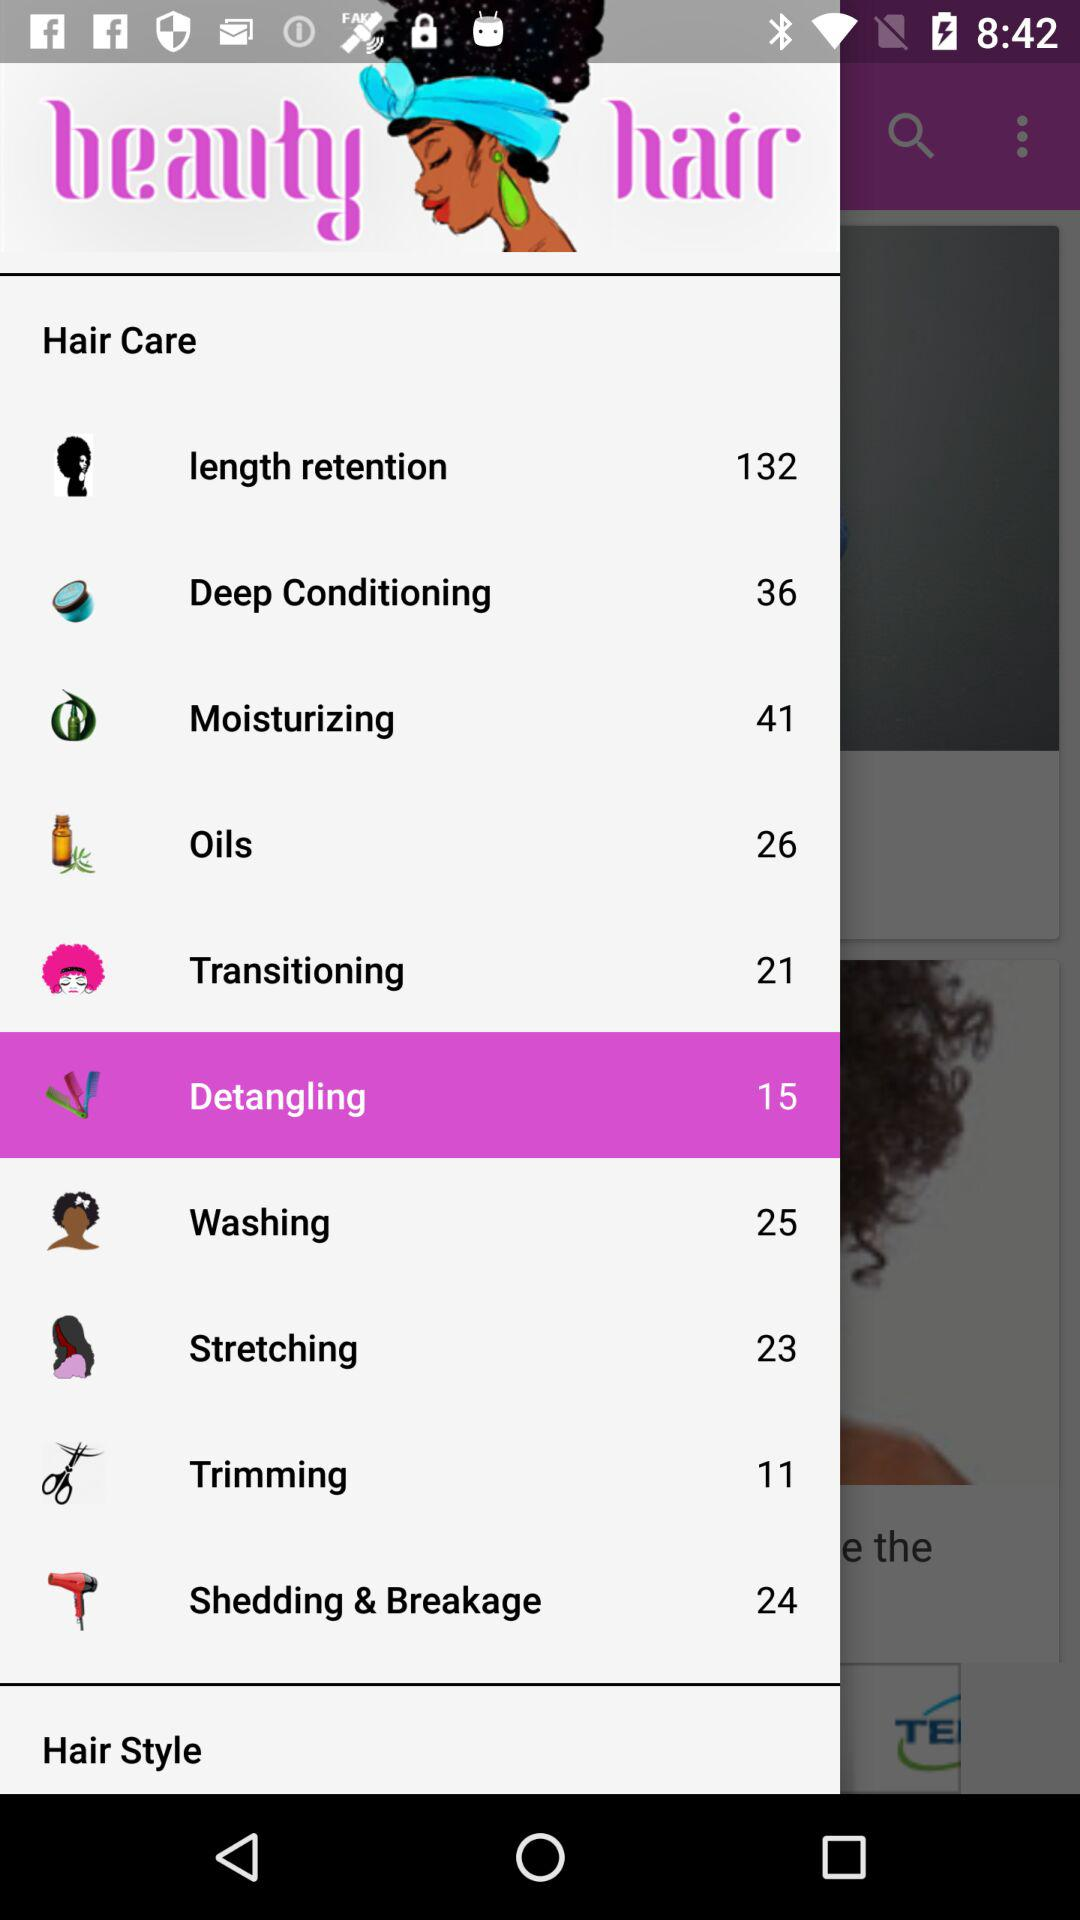What is the application name? The application name is "beauty hair". 